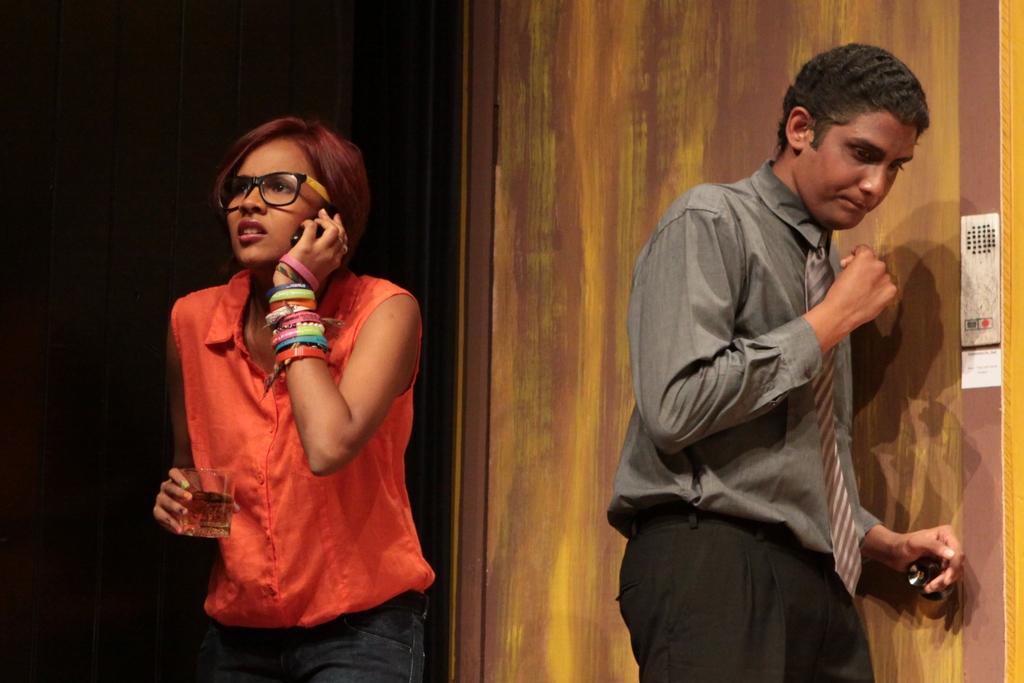Describe this image in one or two sentences. In the image on the left hand side i can see a person holding a glass and talking in the phone and on the right hand i can see a person standing and in the background i can see the wall. 